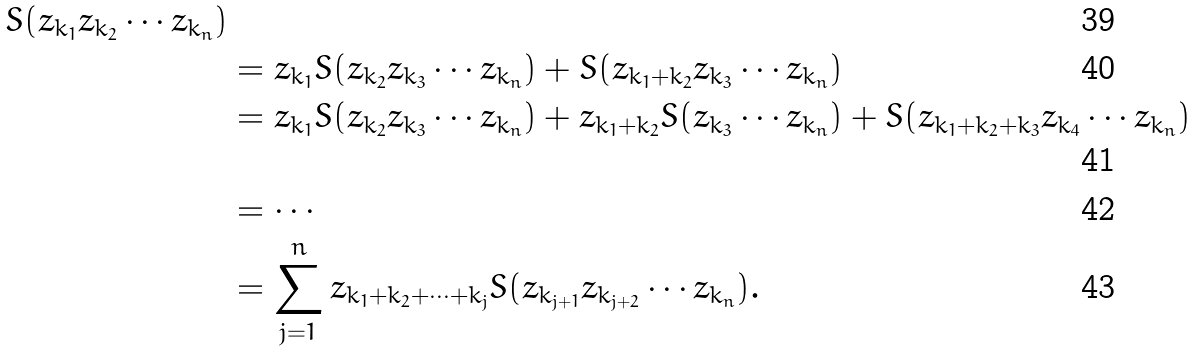Convert formula to latex. <formula><loc_0><loc_0><loc_500><loc_500>{ S ( z _ { k _ { 1 } } z _ { k _ { 2 } } \cdots z _ { k _ { n } } ) } \\ & = z _ { k _ { 1 } } S ( z _ { k _ { 2 } } z _ { k _ { 3 } } \cdots z _ { k _ { n } } ) + S ( z _ { k _ { 1 } + k _ { 2 } } z _ { k _ { 3 } } \cdots z _ { k _ { n } } ) \\ & = z _ { k _ { 1 } } S ( z _ { k _ { 2 } } z _ { k _ { 3 } } \cdots z _ { k _ { n } } ) + z _ { k _ { 1 } + k _ { 2 } } S ( z _ { k _ { 3 } } \cdots z _ { k _ { n } } ) + S ( z _ { k _ { 1 } + k _ { 2 } + k _ { 3 } } z _ { k _ { 4 } } \cdots z _ { k _ { n } } ) \\ & = \cdots \\ & = \sum _ { j = 1 } ^ { n } z _ { k _ { 1 } + k _ { 2 } + \cdots + k _ { j } } S ( z _ { k _ { j + 1 } } z _ { k _ { j + 2 } } \cdots z _ { k _ { n } } ) .</formula> 